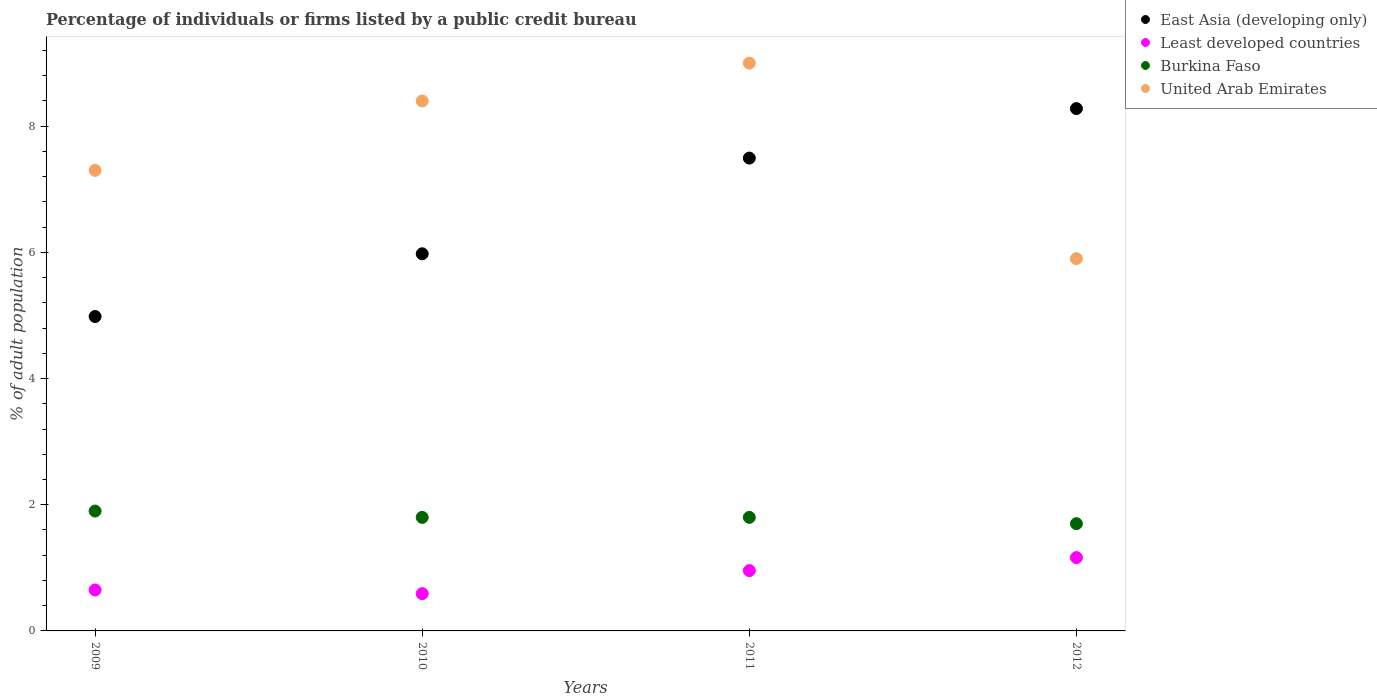Is the number of dotlines equal to the number of legend labels?
Keep it short and to the point. Yes. What is the percentage of population listed by a public credit bureau in Least developed countries in 2010?
Keep it short and to the point. 0.59. Across all years, what is the minimum percentage of population listed by a public credit bureau in Burkina Faso?
Make the answer very short. 1.7. What is the total percentage of population listed by a public credit bureau in Burkina Faso in the graph?
Your response must be concise. 7.2. What is the difference between the percentage of population listed by a public credit bureau in Burkina Faso in 2010 and that in 2011?
Offer a terse response. 0. What is the difference between the percentage of population listed by a public credit bureau in East Asia (developing only) in 2012 and the percentage of population listed by a public credit bureau in United Arab Emirates in 2009?
Offer a very short reply. 0.98. What is the average percentage of population listed by a public credit bureau in United Arab Emirates per year?
Provide a short and direct response. 7.65. In the year 2010, what is the difference between the percentage of population listed by a public credit bureau in Least developed countries and percentage of population listed by a public credit bureau in United Arab Emirates?
Provide a short and direct response. -7.81. What is the ratio of the percentage of population listed by a public credit bureau in United Arab Emirates in 2011 to that in 2012?
Make the answer very short. 1.53. Is the difference between the percentage of population listed by a public credit bureau in Least developed countries in 2009 and 2012 greater than the difference between the percentage of population listed by a public credit bureau in United Arab Emirates in 2009 and 2012?
Keep it short and to the point. No. What is the difference between the highest and the second highest percentage of population listed by a public credit bureau in East Asia (developing only)?
Provide a succinct answer. 0.78. What is the difference between the highest and the lowest percentage of population listed by a public credit bureau in United Arab Emirates?
Offer a terse response. 3.1. In how many years, is the percentage of population listed by a public credit bureau in East Asia (developing only) greater than the average percentage of population listed by a public credit bureau in East Asia (developing only) taken over all years?
Your response must be concise. 2. Is it the case that in every year, the sum of the percentage of population listed by a public credit bureau in Least developed countries and percentage of population listed by a public credit bureau in Burkina Faso  is greater than the percentage of population listed by a public credit bureau in United Arab Emirates?
Your answer should be very brief. No. Is the percentage of population listed by a public credit bureau in Burkina Faso strictly greater than the percentage of population listed by a public credit bureau in Least developed countries over the years?
Provide a short and direct response. Yes. How many years are there in the graph?
Your response must be concise. 4. What is the difference between two consecutive major ticks on the Y-axis?
Offer a very short reply. 2. Are the values on the major ticks of Y-axis written in scientific E-notation?
Keep it short and to the point. No. Does the graph contain any zero values?
Ensure brevity in your answer.  No. What is the title of the graph?
Make the answer very short. Percentage of individuals or firms listed by a public credit bureau. Does "Vietnam" appear as one of the legend labels in the graph?
Your answer should be very brief. No. What is the label or title of the Y-axis?
Ensure brevity in your answer.  % of adult population. What is the % of adult population of East Asia (developing only) in 2009?
Ensure brevity in your answer.  4.98. What is the % of adult population of Least developed countries in 2009?
Your answer should be compact. 0.65. What is the % of adult population in Burkina Faso in 2009?
Your response must be concise. 1.9. What is the % of adult population of United Arab Emirates in 2009?
Make the answer very short. 7.3. What is the % of adult population of East Asia (developing only) in 2010?
Your answer should be very brief. 5.98. What is the % of adult population in Least developed countries in 2010?
Give a very brief answer. 0.59. What is the % of adult population in East Asia (developing only) in 2011?
Your answer should be compact. 7.49. What is the % of adult population in Least developed countries in 2011?
Offer a very short reply. 0.96. What is the % of adult population of East Asia (developing only) in 2012?
Your answer should be compact. 8.28. What is the % of adult population in Least developed countries in 2012?
Your answer should be very brief. 1.16. What is the % of adult population of United Arab Emirates in 2012?
Your answer should be compact. 5.9. Across all years, what is the maximum % of adult population of East Asia (developing only)?
Your answer should be compact. 8.28. Across all years, what is the maximum % of adult population of Least developed countries?
Give a very brief answer. 1.16. Across all years, what is the maximum % of adult population in Burkina Faso?
Give a very brief answer. 1.9. Across all years, what is the minimum % of adult population in East Asia (developing only)?
Offer a very short reply. 4.98. Across all years, what is the minimum % of adult population of Least developed countries?
Ensure brevity in your answer.  0.59. Across all years, what is the minimum % of adult population of United Arab Emirates?
Keep it short and to the point. 5.9. What is the total % of adult population of East Asia (developing only) in the graph?
Your answer should be compact. 26.73. What is the total % of adult population of Least developed countries in the graph?
Make the answer very short. 3.36. What is the total % of adult population in Burkina Faso in the graph?
Your response must be concise. 7.2. What is the total % of adult population in United Arab Emirates in the graph?
Keep it short and to the point. 30.6. What is the difference between the % of adult population in East Asia (developing only) in 2009 and that in 2010?
Your response must be concise. -0.99. What is the difference between the % of adult population in Least developed countries in 2009 and that in 2010?
Make the answer very short. 0.06. What is the difference between the % of adult population in Burkina Faso in 2009 and that in 2010?
Offer a very short reply. 0.1. What is the difference between the % of adult population in East Asia (developing only) in 2009 and that in 2011?
Offer a terse response. -2.51. What is the difference between the % of adult population of Least developed countries in 2009 and that in 2011?
Provide a succinct answer. -0.31. What is the difference between the % of adult population in United Arab Emirates in 2009 and that in 2011?
Your response must be concise. -1.7. What is the difference between the % of adult population in East Asia (developing only) in 2009 and that in 2012?
Make the answer very short. -3.3. What is the difference between the % of adult population of Least developed countries in 2009 and that in 2012?
Make the answer very short. -0.51. What is the difference between the % of adult population of Burkina Faso in 2009 and that in 2012?
Your answer should be very brief. 0.2. What is the difference between the % of adult population in East Asia (developing only) in 2010 and that in 2011?
Give a very brief answer. -1.52. What is the difference between the % of adult population of Least developed countries in 2010 and that in 2011?
Offer a very short reply. -0.37. What is the difference between the % of adult population of Burkina Faso in 2010 and that in 2011?
Offer a terse response. 0. What is the difference between the % of adult population of United Arab Emirates in 2010 and that in 2011?
Offer a very short reply. -0.6. What is the difference between the % of adult population in East Asia (developing only) in 2010 and that in 2012?
Your answer should be very brief. -2.3. What is the difference between the % of adult population in Least developed countries in 2010 and that in 2012?
Provide a short and direct response. -0.57. What is the difference between the % of adult population in United Arab Emirates in 2010 and that in 2012?
Provide a succinct answer. 2.5. What is the difference between the % of adult population of East Asia (developing only) in 2011 and that in 2012?
Your answer should be very brief. -0.78. What is the difference between the % of adult population in Least developed countries in 2011 and that in 2012?
Keep it short and to the point. -0.21. What is the difference between the % of adult population in East Asia (developing only) in 2009 and the % of adult population in Least developed countries in 2010?
Ensure brevity in your answer.  4.39. What is the difference between the % of adult population of East Asia (developing only) in 2009 and the % of adult population of Burkina Faso in 2010?
Your response must be concise. 3.18. What is the difference between the % of adult population of East Asia (developing only) in 2009 and the % of adult population of United Arab Emirates in 2010?
Keep it short and to the point. -3.42. What is the difference between the % of adult population of Least developed countries in 2009 and the % of adult population of Burkina Faso in 2010?
Offer a terse response. -1.15. What is the difference between the % of adult population of Least developed countries in 2009 and the % of adult population of United Arab Emirates in 2010?
Provide a short and direct response. -7.75. What is the difference between the % of adult population of Burkina Faso in 2009 and the % of adult population of United Arab Emirates in 2010?
Offer a terse response. -6.5. What is the difference between the % of adult population in East Asia (developing only) in 2009 and the % of adult population in Least developed countries in 2011?
Give a very brief answer. 4.03. What is the difference between the % of adult population of East Asia (developing only) in 2009 and the % of adult population of Burkina Faso in 2011?
Make the answer very short. 3.18. What is the difference between the % of adult population in East Asia (developing only) in 2009 and the % of adult population in United Arab Emirates in 2011?
Your answer should be very brief. -4.02. What is the difference between the % of adult population of Least developed countries in 2009 and the % of adult population of Burkina Faso in 2011?
Provide a short and direct response. -1.15. What is the difference between the % of adult population in Least developed countries in 2009 and the % of adult population in United Arab Emirates in 2011?
Give a very brief answer. -8.35. What is the difference between the % of adult population in East Asia (developing only) in 2009 and the % of adult population in Least developed countries in 2012?
Provide a succinct answer. 3.82. What is the difference between the % of adult population of East Asia (developing only) in 2009 and the % of adult population of Burkina Faso in 2012?
Ensure brevity in your answer.  3.28. What is the difference between the % of adult population of East Asia (developing only) in 2009 and the % of adult population of United Arab Emirates in 2012?
Provide a succinct answer. -0.92. What is the difference between the % of adult population in Least developed countries in 2009 and the % of adult population in Burkina Faso in 2012?
Provide a succinct answer. -1.05. What is the difference between the % of adult population in Least developed countries in 2009 and the % of adult population in United Arab Emirates in 2012?
Ensure brevity in your answer.  -5.25. What is the difference between the % of adult population in Burkina Faso in 2009 and the % of adult population in United Arab Emirates in 2012?
Your answer should be very brief. -4. What is the difference between the % of adult population in East Asia (developing only) in 2010 and the % of adult population in Least developed countries in 2011?
Provide a succinct answer. 5.02. What is the difference between the % of adult population in East Asia (developing only) in 2010 and the % of adult population in Burkina Faso in 2011?
Give a very brief answer. 4.18. What is the difference between the % of adult population of East Asia (developing only) in 2010 and the % of adult population of United Arab Emirates in 2011?
Offer a terse response. -3.02. What is the difference between the % of adult population of Least developed countries in 2010 and the % of adult population of Burkina Faso in 2011?
Your answer should be compact. -1.21. What is the difference between the % of adult population in Least developed countries in 2010 and the % of adult population in United Arab Emirates in 2011?
Offer a terse response. -8.41. What is the difference between the % of adult population of East Asia (developing only) in 2010 and the % of adult population of Least developed countries in 2012?
Your answer should be very brief. 4.82. What is the difference between the % of adult population in East Asia (developing only) in 2010 and the % of adult population in Burkina Faso in 2012?
Provide a succinct answer. 4.28. What is the difference between the % of adult population in East Asia (developing only) in 2010 and the % of adult population in United Arab Emirates in 2012?
Make the answer very short. 0.08. What is the difference between the % of adult population in Least developed countries in 2010 and the % of adult population in Burkina Faso in 2012?
Make the answer very short. -1.11. What is the difference between the % of adult population of Least developed countries in 2010 and the % of adult population of United Arab Emirates in 2012?
Your answer should be very brief. -5.31. What is the difference between the % of adult population of Burkina Faso in 2010 and the % of adult population of United Arab Emirates in 2012?
Give a very brief answer. -4.1. What is the difference between the % of adult population of East Asia (developing only) in 2011 and the % of adult population of Least developed countries in 2012?
Provide a short and direct response. 6.33. What is the difference between the % of adult population of East Asia (developing only) in 2011 and the % of adult population of Burkina Faso in 2012?
Your answer should be very brief. 5.79. What is the difference between the % of adult population of East Asia (developing only) in 2011 and the % of adult population of United Arab Emirates in 2012?
Keep it short and to the point. 1.59. What is the difference between the % of adult population in Least developed countries in 2011 and the % of adult population in Burkina Faso in 2012?
Give a very brief answer. -0.74. What is the difference between the % of adult population in Least developed countries in 2011 and the % of adult population in United Arab Emirates in 2012?
Provide a short and direct response. -4.94. What is the difference between the % of adult population of Burkina Faso in 2011 and the % of adult population of United Arab Emirates in 2012?
Your answer should be compact. -4.1. What is the average % of adult population of East Asia (developing only) per year?
Ensure brevity in your answer.  6.68. What is the average % of adult population in Least developed countries per year?
Provide a short and direct response. 0.84. What is the average % of adult population of United Arab Emirates per year?
Your answer should be compact. 7.65. In the year 2009, what is the difference between the % of adult population in East Asia (developing only) and % of adult population in Least developed countries?
Your answer should be very brief. 4.33. In the year 2009, what is the difference between the % of adult population of East Asia (developing only) and % of adult population of Burkina Faso?
Offer a very short reply. 3.08. In the year 2009, what is the difference between the % of adult population in East Asia (developing only) and % of adult population in United Arab Emirates?
Your response must be concise. -2.32. In the year 2009, what is the difference between the % of adult population in Least developed countries and % of adult population in Burkina Faso?
Provide a short and direct response. -1.25. In the year 2009, what is the difference between the % of adult population in Least developed countries and % of adult population in United Arab Emirates?
Offer a very short reply. -6.65. In the year 2010, what is the difference between the % of adult population in East Asia (developing only) and % of adult population in Least developed countries?
Keep it short and to the point. 5.39. In the year 2010, what is the difference between the % of adult population of East Asia (developing only) and % of adult population of Burkina Faso?
Provide a short and direct response. 4.18. In the year 2010, what is the difference between the % of adult population of East Asia (developing only) and % of adult population of United Arab Emirates?
Offer a very short reply. -2.42. In the year 2010, what is the difference between the % of adult population of Least developed countries and % of adult population of Burkina Faso?
Ensure brevity in your answer.  -1.21. In the year 2010, what is the difference between the % of adult population of Least developed countries and % of adult population of United Arab Emirates?
Keep it short and to the point. -7.81. In the year 2011, what is the difference between the % of adult population of East Asia (developing only) and % of adult population of Least developed countries?
Give a very brief answer. 6.54. In the year 2011, what is the difference between the % of adult population of East Asia (developing only) and % of adult population of Burkina Faso?
Provide a succinct answer. 5.69. In the year 2011, what is the difference between the % of adult population of East Asia (developing only) and % of adult population of United Arab Emirates?
Keep it short and to the point. -1.51. In the year 2011, what is the difference between the % of adult population of Least developed countries and % of adult population of Burkina Faso?
Provide a succinct answer. -0.84. In the year 2011, what is the difference between the % of adult population of Least developed countries and % of adult population of United Arab Emirates?
Keep it short and to the point. -8.04. In the year 2012, what is the difference between the % of adult population in East Asia (developing only) and % of adult population in Least developed countries?
Give a very brief answer. 7.12. In the year 2012, what is the difference between the % of adult population in East Asia (developing only) and % of adult population in Burkina Faso?
Offer a terse response. 6.58. In the year 2012, what is the difference between the % of adult population of East Asia (developing only) and % of adult population of United Arab Emirates?
Your response must be concise. 2.38. In the year 2012, what is the difference between the % of adult population of Least developed countries and % of adult population of Burkina Faso?
Your answer should be compact. -0.54. In the year 2012, what is the difference between the % of adult population in Least developed countries and % of adult population in United Arab Emirates?
Your answer should be compact. -4.74. What is the ratio of the % of adult population in East Asia (developing only) in 2009 to that in 2010?
Your answer should be compact. 0.83. What is the ratio of the % of adult population in Least developed countries in 2009 to that in 2010?
Your answer should be very brief. 1.1. What is the ratio of the % of adult population of Burkina Faso in 2009 to that in 2010?
Offer a very short reply. 1.06. What is the ratio of the % of adult population in United Arab Emirates in 2009 to that in 2010?
Provide a succinct answer. 0.87. What is the ratio of the % of adult population in East Asia (developing only) in 2009 to that in 2011?
Make the answer very short. 0.66. What is the ratio of the % of adult population of Least developed countries in 2009 to that in 2011?
Give a very brief answer. 0.68. What is the ratio of the % of adult population in Burkina Faso in 2009 to that in 2011?
Make the answer very short. 1.06. What is the ratio of the % of adult population in United Arab Emirates in 2009 to that in 2011?
Your answer should be compact. 0.81. What is the ratio of the % of adult population of East Asia (developing only) in 2009 to that in 2012?
Your answer should be compact. 0.6. What is the ratio of the % of adult population in Least developed countries in 2009 to that in 2012?
Provide a short and direct response. 0.56. What is the ratio of the % of adult population in Burkina Faso in 2009 to that in 2012?
Provide a short and direct response. 1.12. What is the ratio of the % of adult population of United Arab Emirates in 2009 to that in 2012?
Make the answer very short. 1.24. What is the ratio of the % of adult population of East Asia (developing only) in 2010 to that in 2011?
Offer a terse response. 0.8. What is the ratio of the % of adult population of Least developed countries in 2010 to that in 2011?
Your answer should be compact. 0.62. What is the ratio of the % of adult population in East Asia (developing only) in 2010 to that in 2012?
Your response must be concise. 0.72. What is the ratio of the % of adult population of Least developed countries in 2010 to that in 2012?
Keep it short and to the point. 0.51. What is the ratio of the % of adult population of Burkina Faso in 2010 to that in 2012?
Ensure brevity in your answer.  1.06. What is the ratio of the % of adult population in United Arab Emirates in 2010 to that in 2012?
Ensure brevity in your answer.  1.42. What is the ratio of the % of adult population in East Asia (developing only) in 2011 to that in 2012?
Your response must be concise. 0.91. What is the ratio of the % of adult population in Least developed countries in 2011 to that in 2012?
Your response must be concise. 0.82. What is the ratio of the % of adult population in Burkina Faso in 2011 to that in 2012?
Ensure brevity in your answer.  1.06. What is the ratio of the % of adult population of United Arab Emirates in 2011 to that in 2012?
Your answer should be very brief. 1.53. What is the difference between the highest and the second highest % of adult population in East Asia (developing only)?
Ensure brevity in your answer.  0.78. What is the difference between the highest and the second highest % of adult population in Least developed countries?
Your answer should be very brief. 0.21. What is the difference between the highest and the second highest % of adult population of United Arab Emirates?
Provide a succinct answer. 0.6. What is the difference between the highest and the lowest % of adult population of East Asia (developing only)?
Ensure brevity in your answer.  3.3. What is the difference between the highest and the lowest % of adult population in Least developed countries?
Keep it short and to the point. 0.57. What is the difference between the highest and the lowest % of adult population of Burkina Faso?
Give a very brief answer. 0.2. 